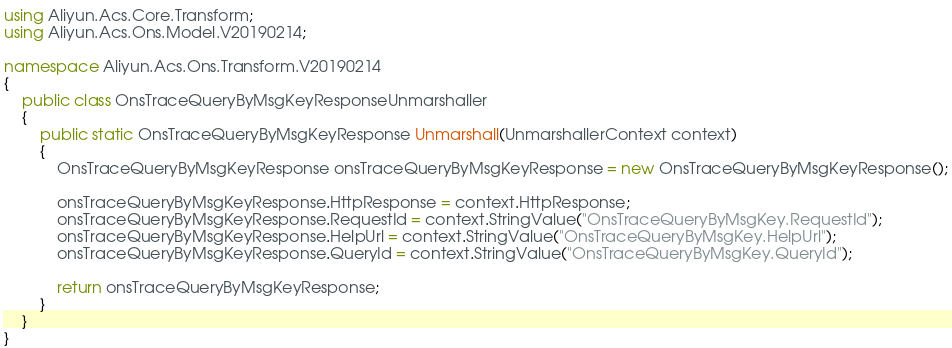<code> <loc_0><loc_0><loc_500><loc_500><_C#_>using Aliyun.Acs.Core.Transform;
using Aliyun.Acs.Ons.Model.V20190214;

namespace Aliyun.Acs.Ons.Transform.V20190214
{
    public class OnsTraceQueryByMsgKeyResponseUnmarshaller
    {
        public static OnsTraceQueryByMsgKeyResponse Unmarshall(UnmarshallerContext context)
        {
			OnsTraceQueryByMsgKeyResponse onsTraceQueryByMsgKeyResponse = new OnsTraceQueryByMsgKeyResponse();

			onsTraceQueryByMsgKeyResponse.HttpResponse = context.HttpResponse;
			onsTraceQueryByMsgKeyResponse.RequestId = context.StringValue("OnsTraceQueryByMsgKey.RequestId");
			onsTraceQueryByMsgKeyResponse.HelpUrl = context.StringValue("OnsTraceQueryByMsgKey.HelpUrl");
			onsTraceQueryByMsgKeyResponse.QueryId = context.StringValue("OnsTraceQueryByMsgKey.QueryId");
        
			return onsTraceQueryByMsgKeyResponse;
        }
    }
}
</code> 